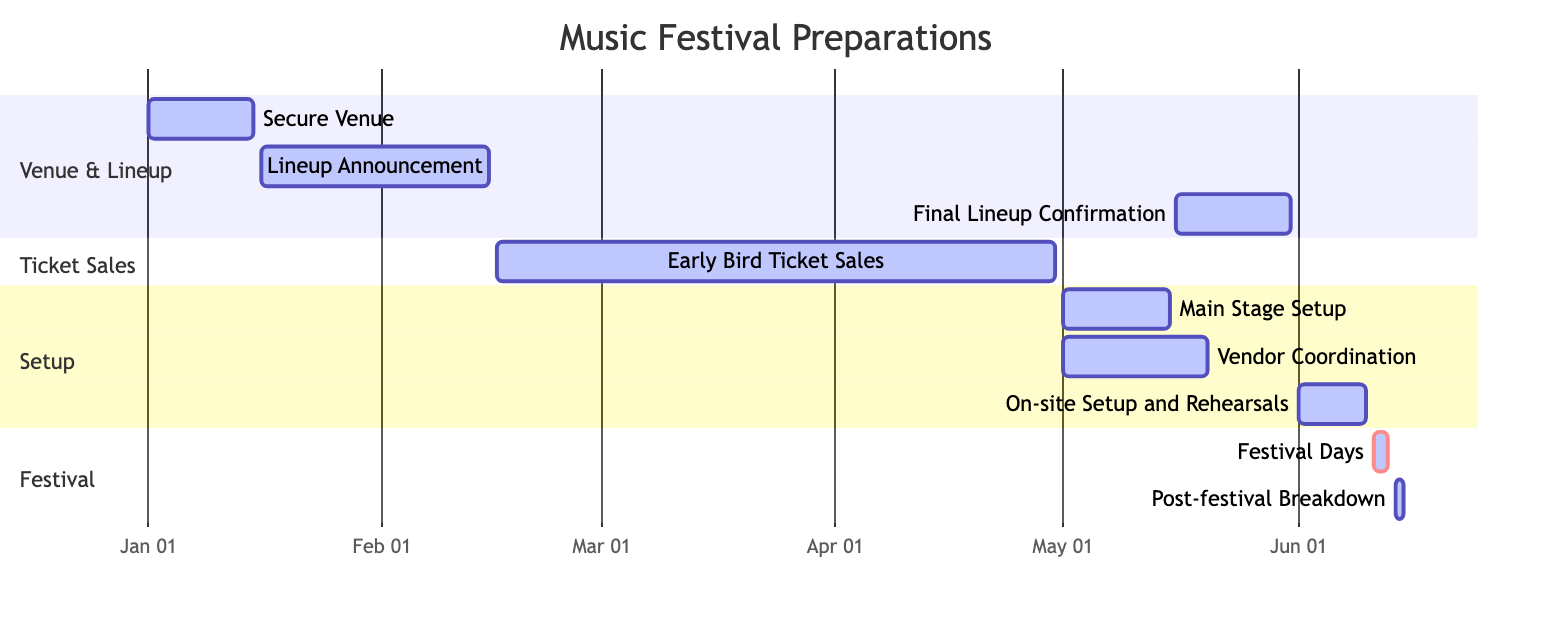What is the duration of the Early Bird Ticket Sales? The Early Bird Ticket Sales task starts on February 16, 2024, and ends on April 30, 2024. Calculating the duration involves counting the days from the start date to the end date, which is a total of 75 days.
Answer: 75 days Which tasks are concurrent with Main Stage Setup? Main Stage Setup overlaps with two tasks: Vendor Coordination and Early Bird Ticket Sales. The start date for Main Stage Setup is May 1, 2024, and ends on May 15, 2024, which overlaps with Vendor Coordination (also starting on May 1) and Early Bird Ticket Sales (which ends on April 30).
Answer: Vendor Coordination, Early Bird Ticket Sales What is the total number of tasks in the diagram? There are nine tasks listed in the diagram related to the music festival preparations. To determine this, we simply count each task section from the data provided.
Answer: 9 tasks When does the Final Lineup Confirmation start? The Final Lineup Confirmation task starts on May 16, 2024, as directly indicated in the timeline data.
Answer: May 16, 2024 How long after the Main Stage Setup does the On-site Setup and Rehearsals begin? Main Stage Setup ends on May 15, 2024, while On-site Setup and Rehearsals begins on June 1, 2024. Calculating the interval between these two dates involves counting 17 days from the end of the Main Stage Setup to the start of the On-site Setup and Rehearsals.
Answer: 17 days What task follows the Festival Days? The task directly following the Festival Days, which occur from June 11 to June 13, 2024, is Post-festival Breakdown that starts on June 14, 2024. This can be determined by observing the sequential arrangement of tasks within the festival section.
Answer: Post-festival Breakdown Which task has the earliest start date? The task with the earliest start date is "Secure Venue," which begins on January 1, 2024. This information can be gathered by examining the start dates of all the tasks in the diagram.
Answer: Secure Venue What is the color designation for the Festival Days task? The Festival Days task is marked as critical in the diagram, typically indicated by a specific color such as red. This designation can be found by noting the style label next to the task in the Gantt diagram.
Answer: Critical 